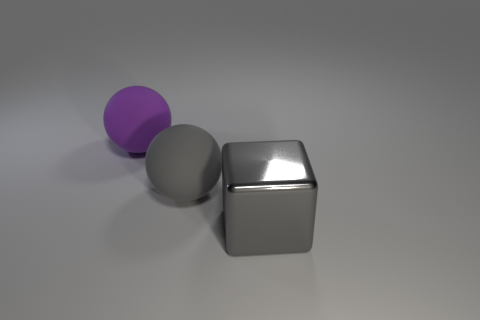There is a purple thing; what number of big gray objects are in front of it?
Your response must be concise. 2. Is there another cube that has the same material as the gray block?
Ensure brevity in your answer.  No. What shape is the large matte object that is the same color as the large cube?
Offer a very short reply. Sphere. There is a large rubber sphere that is in front of the purple sphere; what is its color?
Your response must be concise. Gray. Are there an equal number of large purple matte things in front of the purple ball and big gray shiny objects to the left of the metallic object?
Offer a very short reply. Yes. What is the ball that is behind the rubber ball right of the big purple sphere made of?
Provide a short and direct response. Rubber. What number of objects are either tiny yellow metallic balls or big objects on the right side of the big purple sphere?
Make the answer very short. 2. The other sphere that is made of the same material as the large gray sphere is what size?
Ensure brevity in your answer.  Large. Is the number of large things that are left of the gray shiny block greater than the number of gray rubber spheres?
Give a very brief answer. Yes. Is the size of the rubber thing in front of the purple object the same as the large purple ball?
Give a very brief answer. Yes. 